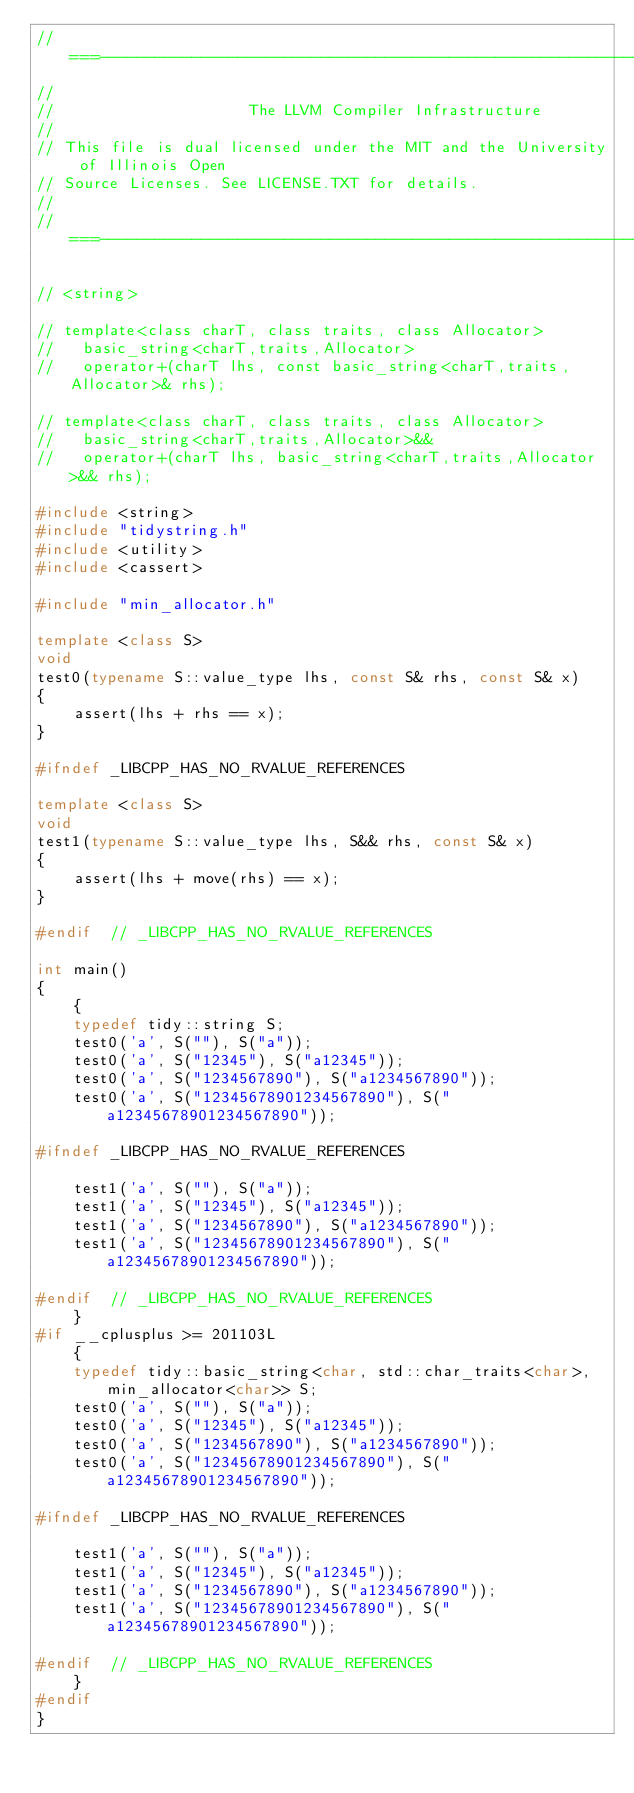Convert code to text. <code><loc_0><loc_0><loc_500><loc_500><_C++_>//===----------------------------------------------------------------------===//
//
//                     The LLVM Compiler Infrastructure
//
// This file is dual licensed under the MIT and the University of Illinois Open
// Source Licenses. See LICENSE.TXT for details.
//
//===----------------------------------------------------------------------===//

// <string>

// template<class charT, class traits, class Allocator>
//   basic_string<charT,traits,Allocator>
//   operator+(charT lhs, const basic_string<charT,traits,Allocator>& rhs);

// template<class charT, class traits, class Allocator>
//   basic_string<charT,traits,Allocator>&&
//   operator+(charT lhs, basic_string<charT,traits,Allocator>&& rhs);

#include <string>
#include "tidystring.h"
#include <utility>
#include <cassert>

#include "min_allocator.h"

template <class S>
void
test0(typename S::value_type lhs, const S& rhs, const S& x)
{
    assert(lhs + rhs == x);
}

#ifndef _LIBCPP_HAS_NO_RVALUE_REFERENCES

template <class S>
void
test1(typename S::value_type lhs, S&& rhs, const S& x)
{
    assert(lhs + move(rhs) == x);
}

#endif  // _LIBCPP_HAS_NO_RVALUE_REFERENCES

int main()
{
    {
    typedef tidy::string S;
    test0('a', S(""), S("a"));
    test0('a', S("12345"), S("a12345"));
    test0('a', S("1234567890"), S("a1234567890"));
    test0('a', S("12345678901234567890"), S("a12345678901234567890"));
    
#ifndef _LIBCPP_HAS_NO_RVALUE_REFERENCES

    test1('a', S(""), S("a"));
    test1('a', S("12345"), S("a12345"));
    test1('a', S("1234567890"), S("a1234567890"));
    test1('a', S("12345678901234567890"), S("a12345678901234567890"));

#endif  // _LIBCPP_HAS_NO_RVALUE_REFERENCES
    }
#if __cplusplus >= 201103L
    {
    typedef tidy::basic_string<char, std::char_traits<char>, min_allocator<char>> S;
    test0('a', S(""), S("a"));
    test0('a', S("12345"), S("a12345"));
    test0('a', S("1234567890"), S("a1234567890"));
    test0('a', S("12345678901234567890"), S("a12345678901234567890"));
    
#ifndef _LIBCPP_HAS_NO_RVALUE_REFERENCES

    test1('a', S(""), S("a"));
    test1('a', S("12345"), S("a12345"));
    test1('a', S("1234567890"), S("a1234567890"));
    test1('a', S("12345678901234567890"), S("a12345678901234567890"));

#endif  // _LIBCPP_HAS_NO_RVALUE_REFERENCES
    }
#endif
}
</code> 